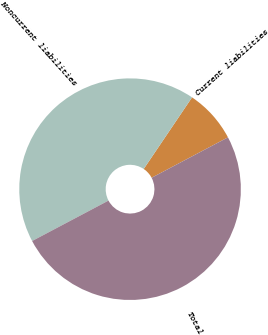<chart> <loc_0><loc_0><loc_500><loc_500><pie_chart><fcel>Current liabilities<fcel>Noncurrent liabilities<fcel>Total<nl><fcel>7.8%<fcel>42.2%<fcel>50.0%<nl></chart> 